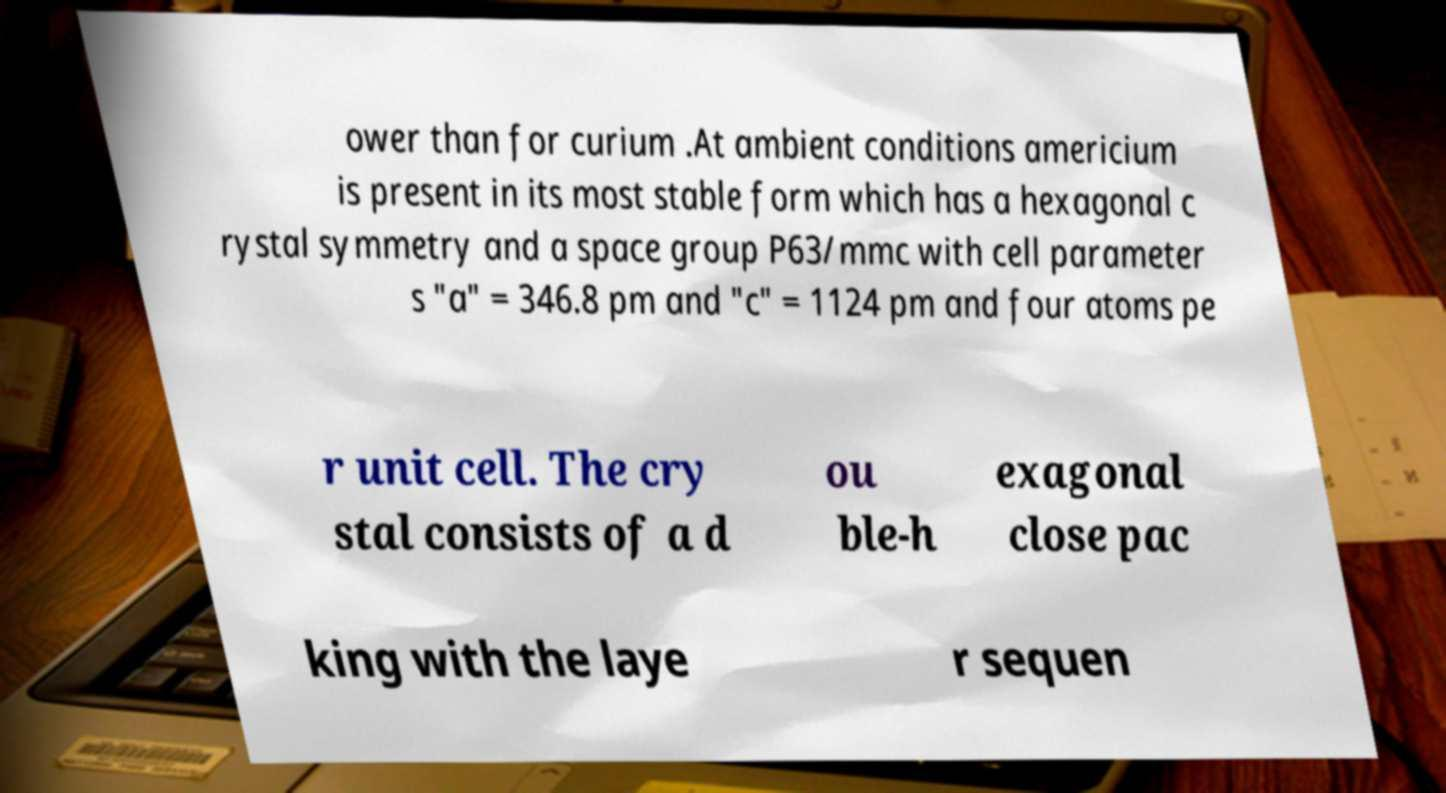What messages or text are displayed in this image? I need them in a readable, typed format. ower than for curium .At ambient conditions americium is present in its most stable form which has a hexagonal c rystal symmetry and a space group P63/mmc with cell parameter s "a" = 346.8 pm and "c" = 1124 pm and four atoms pe r unit cell. The cry stal consists of a d ou ble-h exagonal close pac king with the laye r sequen 